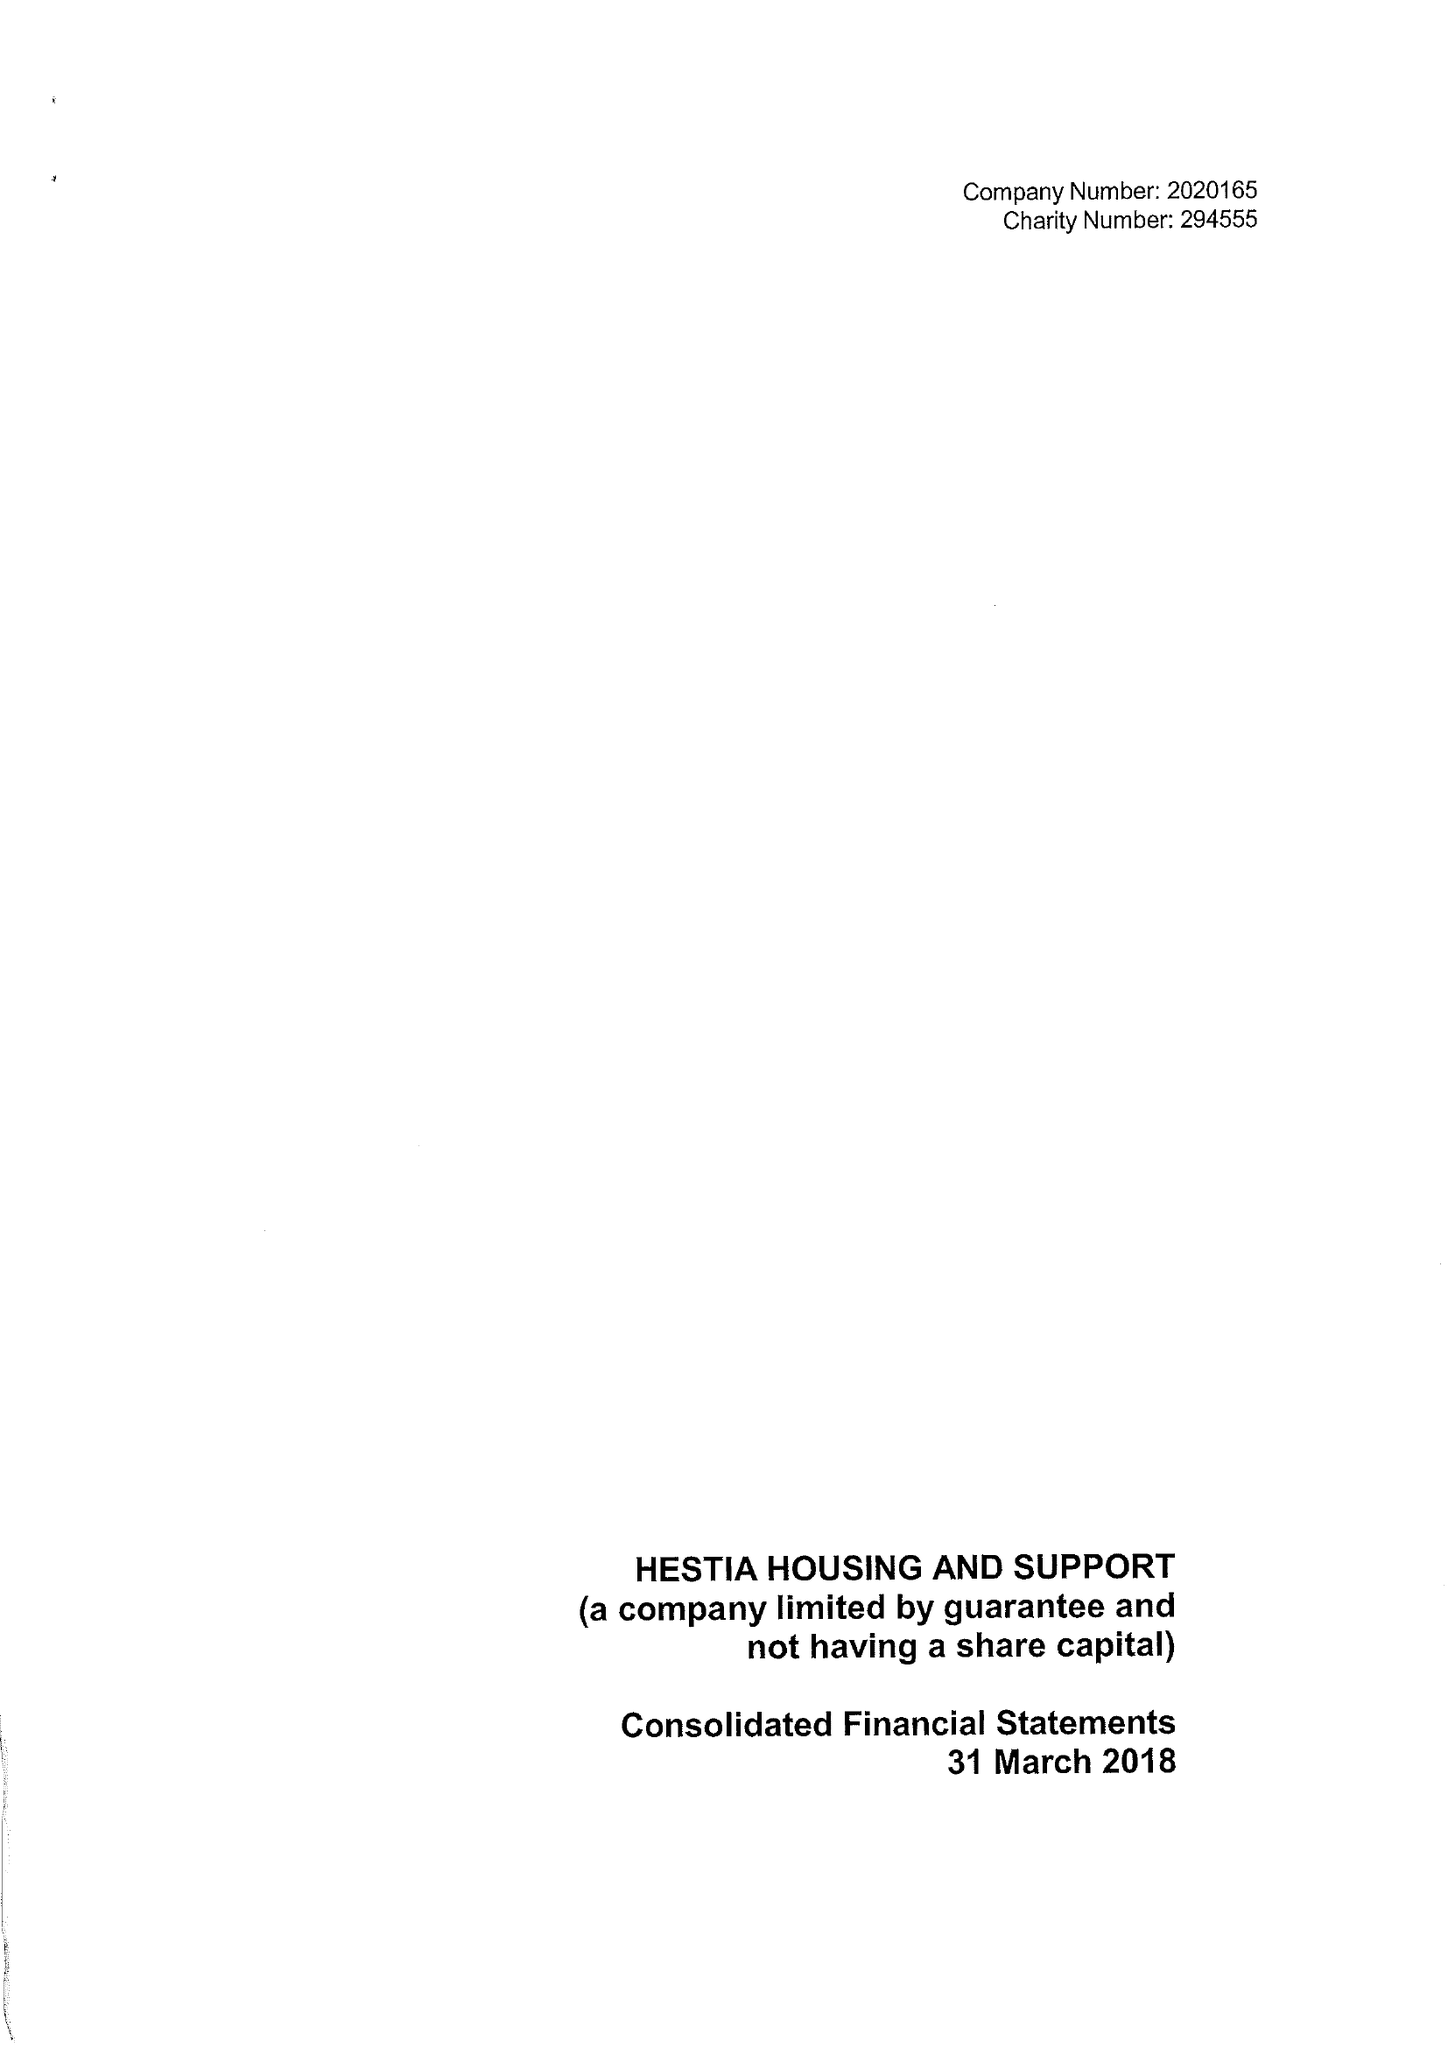What is the value for the spending_annually_in_british_pounds?
Answer the question using a single word or phrase. 26815193.00 